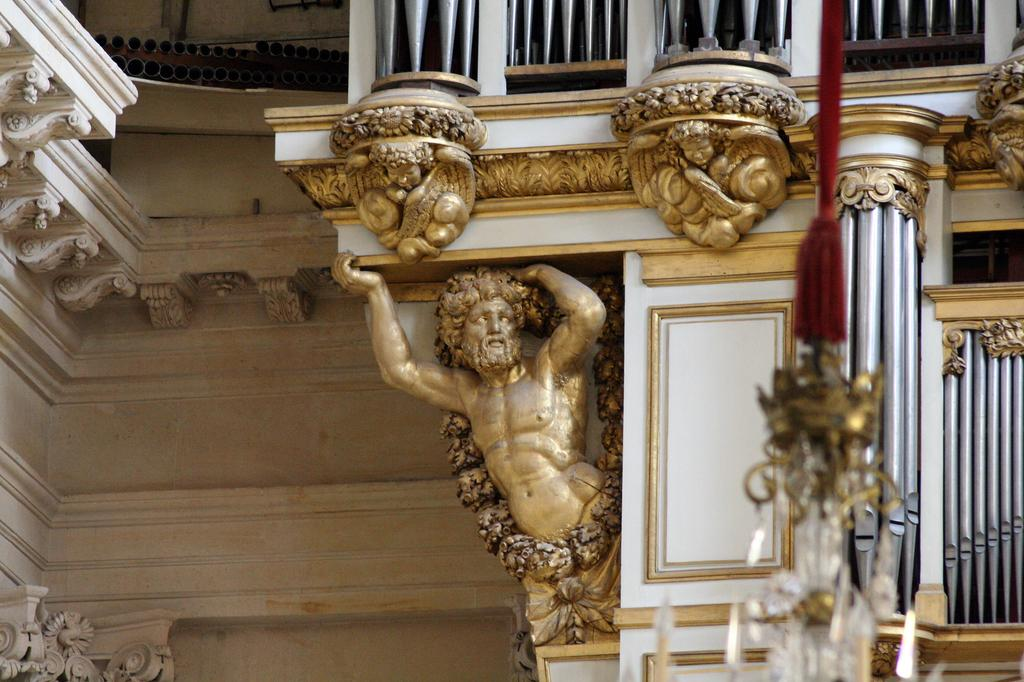What type of location is depicted in the image? The image is an inside view of a building. What is the main feature in the center of the image? There is a sculpture in the center of the image. What architectural elements can be seen in the image? There are walls and pillars visible in the image. What type of lighting fixture is on the right side of the image? There is a chandelier on the right side of the image. What is the chance of finding a circle in the image? There is no mention of a circle in the image, so it cannot be determined if there is a chance of finding one. 